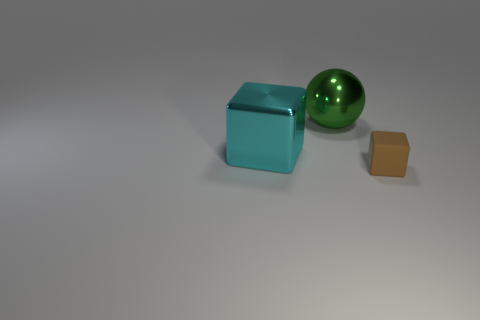Is there anything else that is the same size as the brown rubber cube?
Offer a terse response. No. What number of objects are either brown rubber objects or objects on the left side of the brown object?
Give a very brief answer. 3. There is a thing that is to the right of the big shiny sphere; is its color the same as the metal cube?
Offer a very short reply. No. Are there more green objects that are behind the large green metal thing than big cyan blocks that are on the left side of the cyan metal cube?
Your response must be concise. No. Are there any other things that are the same color as the matte thing?
Provide a succinct answer. No. What number of objects are large cyan cubes or brown matte cubes?
Ensure brevity in your answer.  2. Is the size of the thing behind the cyan metal cube the same as the brown thing?
Make the answer very short. No. What number of other objects are there of the same size as the matte thing?
Give a very brief answer. 0. Are there any big objects?
Ensure brevity in your answer.  Yes. There is a block on the left side of the thing on the right side of the large green ball; how big is it?
Ensure brevity in your answer.  Large. 